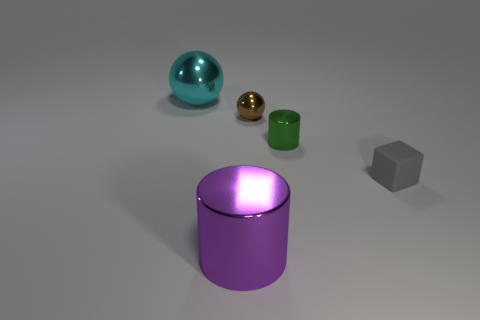The sphere that is on the right side of the big shiny thing that is behind the tiny cube is made of what material? metal 